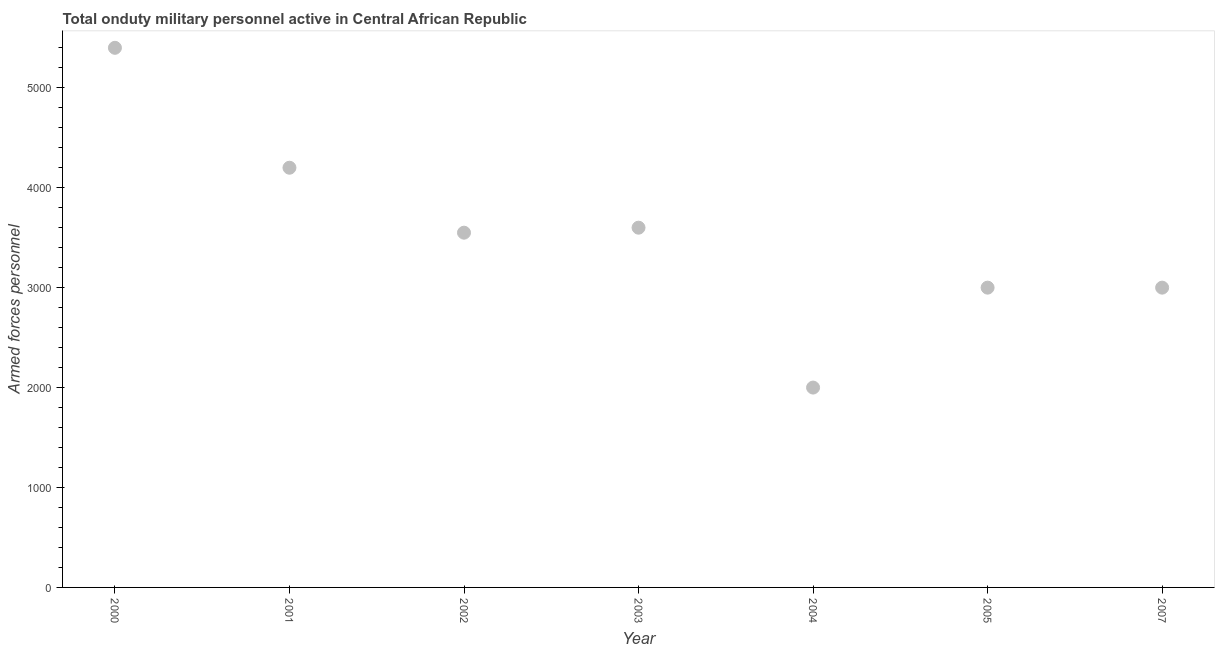What is the number of armed forces personnel in 2007?
Provide a succinct answer. 3000. Across all years, what is the maximum number of armed forces personnel?
Keep it short and to the point. 5400. Across all years, what is the minimum number of armed forces personnel?
Your answer should be compact. 2000. In which year was the number of armed forces personnel maximum?
Your answer should be compact. 2000. What is the sum of the number of armed forces personnel?
Provide a short and direct response. 2.48e+04. What is the difference between the number of armed forces personnel in 2002 and 2007?
Offer a very short reply. 550. What is the average number of armed forces personnel per year?
Keep it short and to the point. 3535.71. What is the median number of armed forces personnel?
Give a very brief answer. 3550. In how many years, is the number of armed forces personnel greater than 1800 ?
Your response must be concise. 7. What is the ratio of the number of armed forces personnel in 2004 to that in 2007?
Keep it short and to the point. 0.67. Is the difference between the number of armed forces personnel in 2003 and 2004 greater than the difference between any two years?
Give a very brief answer. No. What is the difference between the highest and the second highest number of armed forces personnel?
Give a very brief answer. 1200. Is the sum of the number of armed forces personnel in 2004 and 2007 greater than the maximum number of armed forces personnel across all years?
Ensure brevity in your answer.  No. What is the difference between the highest and the lowest number of armed forces personnel?
Ensure brevity in your answer.  3400. In how many years, is the number of armed forces personnel greater than the average number of armed forces personnel taken over all years?
Offer a terse response. 4. Does the number of armed forces personnel monotonically increase over the years?
Offer a very short reply. No. How many dotlines are there?
Give a very brief answer. 1. Are the values on the major ticks of Y-axis written in scientific E-notation?
Make the answer very short. No. What is the title of the graph?
Provide a succinct answer. Total onduty military personnel active in Central African Republic. What is the label or title of the X-axis?
Your answer should be very brief. Year. What is the label or title of the Y-axis?
Give a very brief answer. Armed forces personnel. What is the Armed forces personnel in 2000?
Provide a short and direct response. 5400. What is the Armed forces personnel in 2001?
Offer a terse response. 4200. What is the Armed forces personnel in 2002?
Your response must be concise. 3550. What is the Armed forces personnel in 2003?
Keep it short and to the point. 3600. What is the Armed forces personnel in 2004?
Offer a terse response. 2000. What is the Armed forces personnel in 2005?
Keep it short and to the point. 3000. What is the Armed forces personnel in 2007?
Provide a succinct answer. 3000. What is the difference between the Armed forces personnel in 2000 and 2001?
Give a very brief answer. 1200. What is the difference between the Armed forces personnel in 2000 and 2002?
Give a very brief answer. 1850. What is the difference between the Armed forces personnel in 2000 and 2003?
Keep it short and to the point. 1800. What is the difference between the Armed forces personnel in 2000 and 2004?
Give a very brief answer. 3400. What is the difference between the Armed forces personnel in 2000 and 2005?
Give a very brief answer. 2400. What is the difference between the Armed forces personnel in 2000 and 2007?
Your answer should be very brief. 2400. What is the difference between the Armed forces personnel in 2001 and 2002?
Your response must be concise. 650. What is the difference between the Armed forces personnel in 2001 and 2003?
Make the answer very short. 600. What is the difference between the Armed forces personnel in 2001 and 2004?
Ensure brevity in your answer.  2200. What is the difference between the Armed forces personnel in 2001 and 2005?
Provide a short and direct response. 1200. What is the difference between the Armed forces personnel in 2001 and 2007?
Make the answer very short. 1200. What is the difference between the Armed forces personnel in 2002 and 2004?
Provide a succinct answer. 1550. What is the difference between the Armed forces personnel in 2002 and 2005?
Keep it short and to the point. 550. What is the difference between the Armed forces personnel in 2002 and 2007?
Your response must be concise. 550. What is the difference between the Armed forces personnel in 2003 and 2004?
Give a very brief answer. 1600. What is the difference between the Armed forces personnel in 2003 and 2005?
Make the answer very short. 600. What is the difference between the Armed forces personnel in 2003 and 2007?
Provide a succinct answer. 600. What is the difference between the Armed forces personnel in 2004 and 2005?
Provide a short and direct response. -1000. What is the difference between the Armed forces personnel in 2004 and 2007?
Make the answer very short. -1000. What is the difference between the Armed forces personnel in 2005 and 2007?
Your answer should be compact. 0. What is the ratio of the Armed forces personnel in 2000 to that in 2001?
Provide a short and direct response. 1.29. What is the ratio of the Armed forces personnel in 2000 to that in 2002?
Your response must be concise. 1.52. What is the ratio of the Armed forces personnel in 2000 to that in 2004?
Offer a terse response. 2.7. What is the ratio of the Armed forces personnel in 2001 to that in 2002?
Give a very brief answer. 1.18. What is the ratio of the Armed forces personnel in 2001 to that in 2003?
Give a very brief answer. 1.17. What is the ratio of the Armed forces personnel in 2001 to that in 2005?
Make the answer very short. 1.4. What is the ratio of the Armed forces personnel in 2001 to that in 2007?
Give a very brief answer. 1.4. What is the ratio of the Armed forces personnel in 2002 to that in 2003?
Offer a very short reply. 0.99. What is the ratio of the Armed forces personnel in 2002 to that in 2004?
Make the answer very short. 1.77. What is the ratio of the Armed forces personnel in 2002 to that in 2005?
Give a very brief answer. 1.18. What is the ratio of the Armed forces personnel in 2002 to that in 2007?
Give a very brief answer. 1.18. What is the ratio of the Armed forces personnel in 2003 to that in 2005?
Offer a terse response. 1.2. What is the ratio of the Armed forces personnel in 2004 to that in 2005?
Keep it short and to the point. 0.67. What is the ratio of the Armed forces personnel in 2004 to that in 2007?
Keep it short and to the point. 0.67. 